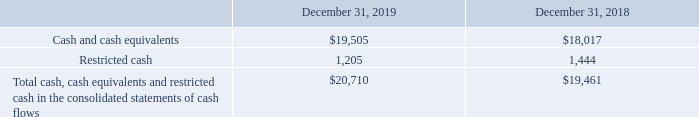(l) Cash, Cash Equivalents and Restricted Cash
Cash equivalents consist of highly liquid investments with maturities of three months or less on the date of purchase. Restricted cash includes cash and cash equivalents that is restricted through legal contracts, regulations or our intention to use the cash for a specific purpose. Our restricted cash primarily relates to refundable deposits and funds held in escrow.
The following table provides a reconciliation of cash, cash equivalents and restricted cash reported within the consolidated balance sheets to the total amounts shown in the statements of cash flows (in thousands):
What is the cash and cash equivalents as of December 31, 2019 and 2018 respectively?
Answer scale should be: thousand. $19,505, $18,017. What is the restricted cash amount as of December 31, 2019 and 2018 respectively?
Answer scale should be: thousand. 1,205, 1,444. What does restricted cash primarily relate to? Refundable deposits and funds held in escrow. What is the change in the cash and cash equivalents between 2019 and 2018?
Answer scale should be: thousand. 19,505-18,017
Answer: 1488. What is the average restricted cash amount in 2018 and 2019?
Answer scale should be: thousand. (1,205+1,444)/2
Answer: 1324.5. Which year has the higher amount of cash and cash equivalents? Look at COL3 and COL4 , and compare the values at Row 2 
Answer: 2019. 